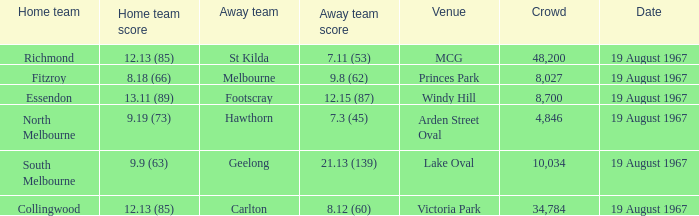Can you parse all the data within this table? {'header': ['Home team', 'Home team score', 'Away team', 'Away team score', 'Venue', 'Crowd', 'Date'], 'rows': [['Richmond', '12.13 (85)', 'St Kilda', '7.11 (53)', 'MCG', '48,200', '19 August 1967'], ['Fitzroy', '8.18 (66)', 'Melbourne', '9.8 (62)', 'Princes Park', '8,027', '19 August 1967'], ['Essendon', '13.11 (89)', 'Footscray', '12.15 (87)', 'Windy Hill', '8,700', '19 August 1967'], ['North Melbourne', '9.19 (73)', 'Hawthorn', '7.3 (45)', 'Arden Street Oval', '4,846', '19 August 1967'], ['South Melbourne', '9.9 (63)', 'Geelong', '21.13 (139)', 'Lake Oval', '10,034', '19 August 1967'], ['Collingwood', '12.13 (85)', 'Carlton', '8.12 (60)', 'Victoria Park', '34,784', '19 August 1967']]} What was the away team's score during their match against collingwood? 8.12 (60). 